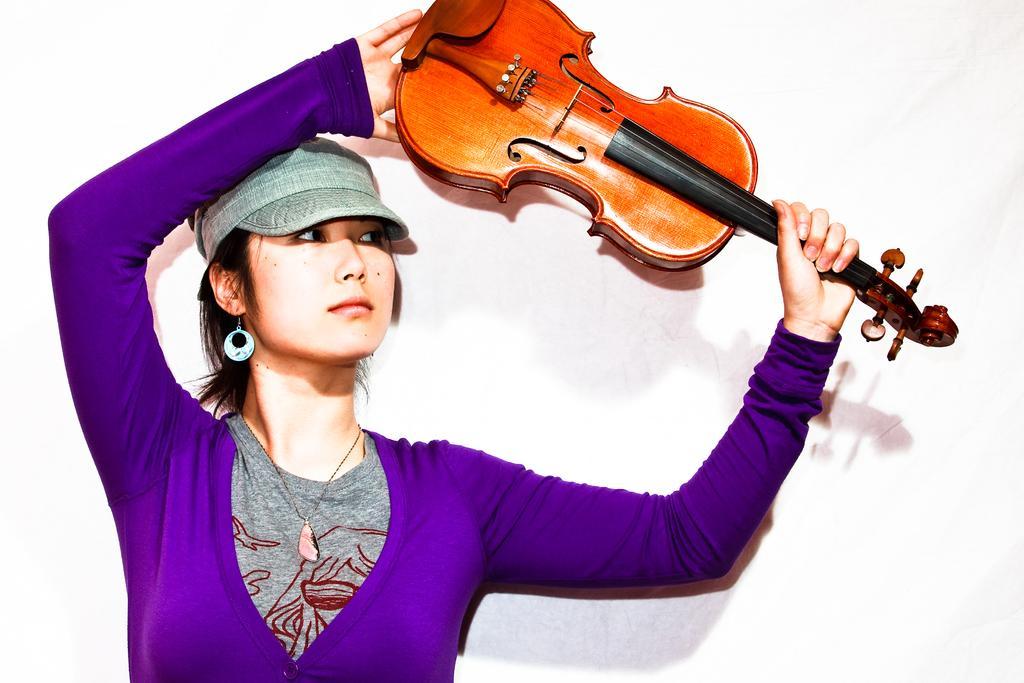In one or two sentences, can you explain what this image depicts? As we can see in the image there is a woman holding guitar. 